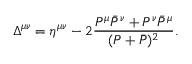Convert formula to latex. <formula><loc_0><loc_0><loc_500><loc_500>\Delta ^ { \mu \nu } = \eta ^ { \mu \nu } - 2 \frac { P ^ { \mu } \bar { P } ^ { \nu } + P ^ { \nu } \bar { P } ^ { \mu } } { ( P + \bar { P } ) ^ { 2 } } .</formula> 